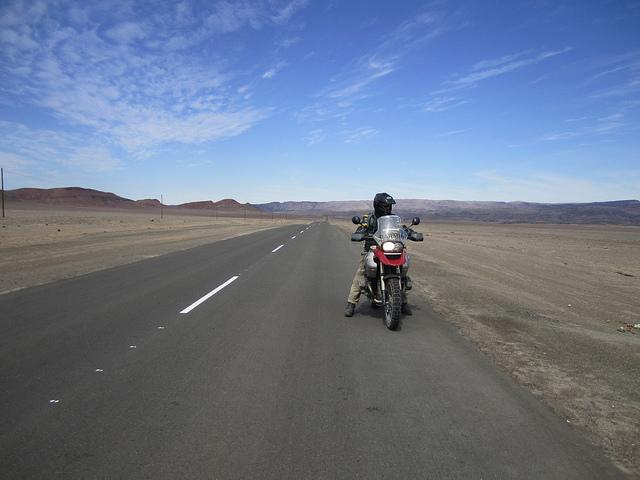Does this look like a wooded area?
Short answer required. No. How many bikes are on the road?
Give a very brief answer. 1. Is the bike moving?
Keep it brief. No. Are these men racing down a road?
Short answer required. No. What color stripe runs down the middle of the roadway?
Answer briefly. White. Is the rider about to race?
Be succinct. No. 